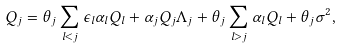Convert formula to latex. <formula><loc_0><loc_0><loc_500><loc_500>Q _ { j } = \theta _ { j } \sum _ { l < j } \epsilon _ { l } \alpha _ { l } Q _ { l } + \alpha _ { j } Q _ { j } \Lambda _ { j } + \theta _ { j } \sum _ { l > j } \alpha _ { l } Q _ { l } + \theta _ { j } \sigma ^ { 2 } ,</formula> 